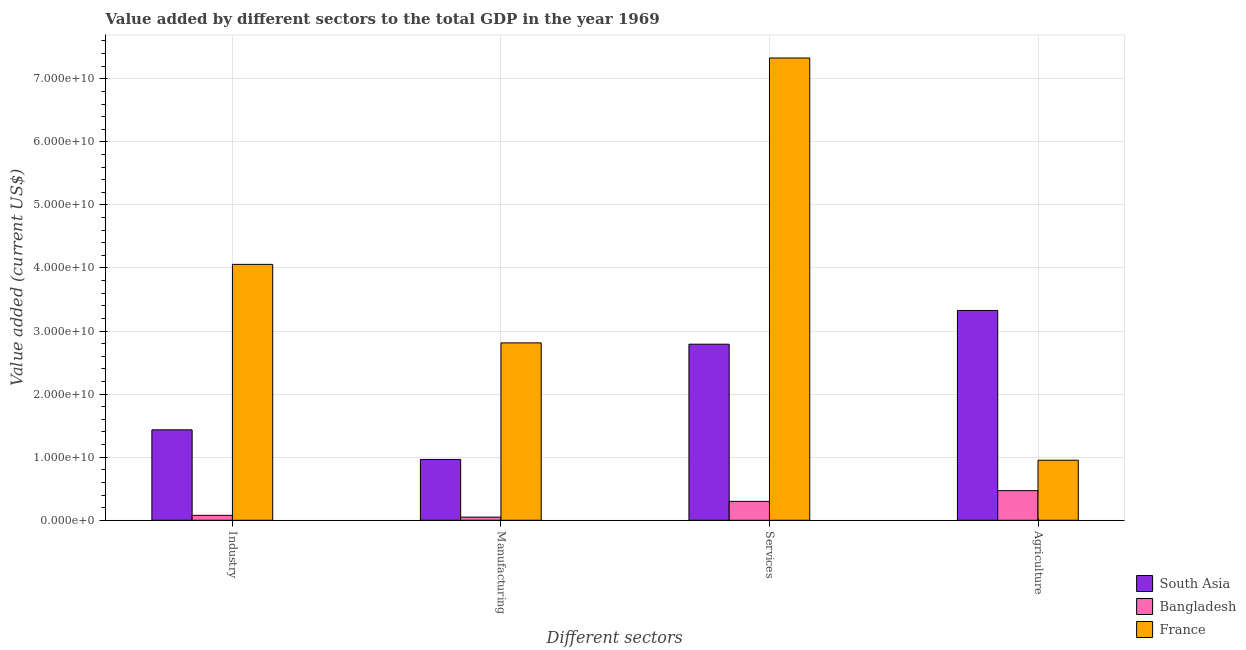How many different coloured bars are there?
Your response must be concise. 3. Are the number of bars per tick equal to the number of legend labels?
Offer a very short reply. Yes. Are the number of bars on each tick of the X-axis equal?
Keep it short and to the point. Yes. How many bars are there on the 1st tick from the left?
Your answer should be very brief. 3. How many bars are there on the 4th tick from the right?
Offer a terse response. 3. What is the label of the 2nd group of bars from the left?
Your answer should be very brief. Manufacturing. What is the value added by industrial sector in France?
Make the answer very short. 4.06e+1. Across all countries, what is the maximum value added by services sector?
Offer a very short reply. 7.33e+1. Across all countries, what is the minimum value added by services sector?
Provide a succinct answer. 3.00e+09. In which country was the value added by manufacturing sector maximum?
Keep it short and to the point. France. In which country was the value added by manufacturing sector minimum?
Your response must be concise. Bangladesh. What is the total value added by services sector in the graph?
Provide a short and direct response. 1.04e+11. What is the difference between the value added by agricultural sector in France and that in Bangladesh?
Give a very brief answer. 4.83e+09. What is the difference between the value added by services sector in South Asia and the value added by agricultural sector in Bangladesh?
Provide a short and direct response. 2.32e+1. What is the average value added by industrial sector per country?
Your answer should be compact. 1.86e+1. What is the difference between the value added by agricultural sector and value added by services sector in South Asia?
Provide a succinct answer. 5.35e+09. In how many countries, is the value added by services sector greater than 70000000000 US$?
Provide a succinct answer. 1. What is the ratio of the value added by industrial sector in France to that in Bangladesh?
Give a very brief answer. 52.14. Is the difference between the value added by services sector in Bangladesh and France greater than the difference between the value added by agricultural sector in Bangladesh and France?
Offer a terse response. No. What is the difference between the highest and the second highest value added by industrial sector?
Your answer should be compact. 2.62e+1. What is the difference between the highest and the lowest value added by manufacturing sector?
Provide a short and direct response. 2.76e+1. In how many countries, is the value added by manufacturing sector greater than the average value added by manufacturing sector taken over all countries?
Provide a short and direct response. 1. Are the values on the major ticks of Y-axis written in scientific E-notation?
Keep it short and to the point. Yes. How many legend labels are there?
Your response must be concise. 3. How are the legend labels stacked?
Offer a terse response. Vertical. What is the title of the graph?
Your answer should be very brief. Value added by different sectors to the total GDP in the year 1969. Does "Kenya" appear as one of the legend labels in the graph?
Your answer should be very brief. No. What is the label or title of the X-axis?
Make the answer very short. Different sectors. What is the label or title of the Y-axis?
Give a very brief answer. Value added (current US$). What is the Value added (current US$) in South Asia in Industry?
Give a very brief answer. 1.43e+1. What is the Value added (current US$) of Bangladesh in Industry?
Provide a succinct answer. 7.78e+08. What is the Value added (current US$) in France in Industry?
Offer a terse response. 4.06e+1. What is the Value added (current US$) in South Asia in Manufacturing?
Your answer should be compact. 9.64e+09. What is the Value added (current US$) of Bangladesh in Manufacturing?
Give a very brief answer. 4.96e+08. What is the Value added (current US$) of France in Manufacturing?
Offer a very short reply. 2.81e+1. What is the Value added (current US$) in South Asia in Services?
Offer a very short reply. 2.79e+1. What is the Value added (current US$) of Bangladesh in Services?
Offer a terse response. 3.00e+09. What is the Value added (current US$) of France in Services?
Your answer should be very brief. 7.33e+1. What is the Value added (current US$) of South Asia in Agriculture?
Your answer should be compact. 3.33e+1. What is the Value added (current US$) of Bangladesh in Agriculture?
Provide a succinct answer. 4.69e+09. What is the Value added (current US$) in France in Agriculture?
Offer a very short reply. 9.52e+09. Across all Different sectors, what is the maximum Value added (current US$) of South Asia?
Make the answer very short. 3.33e+1. Across all Different sectors, what is the maximum Value added (current US$) of Bangladesh?
Make the answer very short. 4.69e+09. Across all Different sectors, what is the maximum Value added (current US$) in France?
Your answer should be compact. 7.33e+1. Across all Different sectors, what is the minimum Value added (current US$) in South Asia?
Offer a very short reply. 9.64e+09. Across all Different sectors, what is the minimum Value added (current US$) of Bangladesh?
Offer a terse response. 4.96e+08. Across all Different sectors, what is the minimum Value added (current US$) in France?
Your response must be concise. 9.52e+09. What is the total Value added (current US$) in South Asia in the graph?
Your answer should be compact. 8.52e+1. What is the total Value added (current US$) in Bangladesh in the graph?
Provide a succinct answer. 8.97e+09. What is the total Value added (current US$) of France in the graph?
Offer a very short reply. 1.52e+11. What is the difference between the Value added (current US$) in South Asia in Industry and that in Manufacturing?
Provide a succinct answer. 4.69e+09. What is the difference between the Value added (current US$) of Bangladesh in Industry and that in Manufacturing?
Offer a terse response. 2.83e+08. What is the difference between the Value added (current US$) in France in Industry and that in Manufacturing?
Provide a succinct answer. 1.24e+1. What is the difference between the Value added (current US$) of South Asia in Industry and that in Services?
Give a very brief answer. -1.36e+1. What is the difference between the Value added (current US$) of Bangladesh in Industry and that in Services?
Your answer should be compact. -2.22e+09. What is the difference between the Value added (current US$) of France in Industry and that in Services?
Keep it short and to the point. -3.27e+1. What is the difference between the Value added (current US$) in South Asia in Industry and that in Agriculture?
Offer a terse response. -1.89e+1. What is the difference between the Value added (current US$) of Bangladesh in Industry and that in Agriculture?
Keep it short and to the point. -3.92e+09. What is the difference between the Value added (current US$) of France in Industry and that in Agriculture?
Provide a succinct answer. 3.11e+1. What is the difference between the Value added (current US$) of South Asia in Manufacturing and that in Services?
Give a very brief answer. -1.83e+1. What is the difference between the Value added (current US$) in Bangladesh in Manufacturing and that in Services?
Provide a short and direct response. -2.50e+09. What is the difference between the Value added (current US$) in France in Manufacturing and that in Services?
Provide a succinct answer. -4.52e+1. What is the difference between the Value added (current US$) in South Asia in Manufacturing and that in Agriculture?
Your answer should be very brief. -2.36e+1. What is the difference between the Value added (current US$) of Bangladesh in Manufacturing and that in Agriculture?
Provide a short and direct response. -4.20e+09. What is the difference between the Value added (current US$) in France in Manufacturing and that in Agriculture?
Make the answer very short. 1.86e+1. What is the difference between the Value added (current US$) of South Asia in Services and that in Agriculture?
Provide a succinct answer. -5.35e+09. What is the difference between the Value added (current US$) of Bangladesh in Services and that in Agriculture?
Your answer should be compact. -1.70e+09. What is the difference between the Value added (current US$) of France in Services and that in Agriculture?
Keep it short and to the point. 6.38e+1. What is the difference between the Value added (current US$) in South Asia in Industry and the Value added (current US$) in Bangladesh in Manufacturing?
Provide a short and direct response. 1.38e+1. What is the difference between the Value added (current US$) of South Asia in Industry and the Value added (current US$) of France in Manufacturing?
Your answer should be very brief. -1.38e+1. What is the difference between the Value added (current US$) in Bangladesh in Industry and the Value added (current US$) in France in Manufacturing?
Ensure brevity in your answer.  -2.73e+1. What is the difference between the Value added (current US$) of South Asia in Industry and the Value added (current US$) of Bangladesh in Services?
Your response must be concise. 1.13e+1. What is the difference between the Value added (current US$) in South Asia in Industry and the Value added (current US$) in France in Services?
Offer a terse response. -5.90e+1. What is the difference between the Value added (current US$) in Bangladesh in Industry and the Value added (current US$) in France in Services?
Your answer should be very brief. -7.25e+1. What is the difference between the Value added (current US$) in South Asia in Industry and the Value added (current US$) in Bangladesh in Agriculture?
Provide a succinct answer. 9.64e+09. What is the difference between the Value added (current US$) in South Asia in Industry and the Value added (current US$) in France in Agriculture?
Your answer should be very brief. 4.81e+09. What is the difference between the Value added (current US$) in Bangladesh in Industry and the Value added (current US$) in France in Agriculture?
Provide a succinct answer. -8.75e+09. What is the difference between the Value added (current US$) in South Asia in Manufacturing and the Value added (current US$) in Bangladesh in Services?
Keep it short and to the point. 6.64e+09. What is the difference between the Value added (current US$) in South Asia in Manufacturing and the Value added (current US$) in France in Services?
Provide a short and direct response. -6.37e+1. What is the difference between the Value added (current US$) of Bangladesh in Manufacturing and the Value added (current US$) of France in Services?
Provide a succinct answer. -7.28e+1. What is the difference between the Value added (current US$) in South Asia in Manufacturing and the Value added (current US$) in Bangladesh in Agriculture?
Your answer should be very brief. 4.95e+09. What is the difference between the Value added (current US$) in South Asia in Manufacturing and the Value added (current US$) in France in Agriculture?
Make the answer very short. 1.19e+08. What is the difference between the Value added (current US$) of Bangladesh in Manufacturing and the Value added (current US$) of France in Agriculture?
Offer a very short reply. -9.03e+09. What is the difference between the Value added (current US$) of South Asia in Services and the Value added (current US$) of Bangladesh in Agriculture?
Your answer should be very brief. 2.32e+1. What is the difference between the Value added (current US$) of South Asia in Services and the Value added (current US$) of France in Agriculture?
Your answer should be very brief. 1.84e+1. What is the difference between the Value added (current US$) in Bangladesh in Services and the Value added (current US$) in France in Agriculture?
Provide a short and direct response. -6.52e+09. What is the average Value added (current US$) of South Asia per Different sectors?
Offer a terse response. 2.13e+1. What is the average Value added (current US$) of Bangladesh per Different sectors?
Provide a short and direct response. 2.24e+09. What is the average Value added (current US$) of France per Different sectors?
Give a very brief answer. 3.79e+1. What is the difference between the Value added (current US$) in South Asia and Value added (current US$) in Bangladesh in Industry?
Provide a short and direct response. 1.36e+1. What is the difference between the Value added (current US$) of South Asia and Value added (current US$) of France in Industry?
Keep it short and to the point. -2.62e+1. What is the difference between the Value added (current US$) in Bangladesh and Value added (current US$) in France in Industry?
Keep it short and to the point. -3.98e+1. What is the difference between the Value added (current US$) in South Asia and Value added (current US$) in Bangladesh in Manufacturing?
Offer a terse response. 9.15e+09. What is the difference between the Value added (current US$) of South Asia and Value added (current US$) of France in Manufacturing?
Your answer should be very brief. -1.85e+1. What is the difference between the Value added (current US$) of Bangladesh and Value added (current US$) of France in Manufacturing?
Your response must be concise. -2.76e+1. What is the difference between the Value added (current US$) of South Asia and Value added (current US$) of Bangladesh in Services?
Ensure brevity in your answer.  2.49e+1. What is the difference between the Value added (current US$) of South Asia and Value added (current US$) of France in Services?
Your response must be concise. -4.54e+1. What is the difference between the Value added (current US$) in Bangladesh and Value added (current US$) in France in Services?
Make the answer very short. -7.03e+1. What is the difference between the Value added (current US$) of South Asia and Value added (current US$) of Bangladesh in Agriculture?
Offer a terse response. 2.86e+1. What is the difference between the Value added (current US$) of South Asia and Value added (current US$) of France in Agriculture?
Provide a short and direct response. 2.37e+1. What is the difference between the Value added (current US$) in Bangladesh and Value added (current US$) in France in Agriculture?
Give a very brief answer. -4.83e+09. What is the ratio of the Value added (current US$) of South Asia in Industry to that in Manufacturing?
Ensure brevity in your answer.  1.49. What is the ratio of the Value added (current US$) of Bangladesh in Industry to that in Manufacturing?
Offer a terse response. 1.57. What is the ratio of the Value added (current US$) in France in Industry to that in Manufacturing?
Ensure brevity in your answer.  1.44. What is the ratio of the Value added (current US$) of South Asia in Industry to that in Services?
Keep it short and to the point. 0.51. What is the ratio of the Value added (current US$) in Bangladesh in Industry to that in Services?
Provide a succinct answer. 0.26. What is the ratio of the Value added (current US$) in France in Industry to that in Services?
Your answer should be very brief. 0.55. What is the ratio of the Value added (current US$) in South Asia in Industry to that in Agriculture?
Give a very brief answer. 0.43. What is the ratio of the Value added (current US$) in Bangladesh in Industry to that in Agriculture?
Your answer should be very brief. 0.17. What is the ratio of the Value added (current US$) in France in Industry to that in Agriculture?
Ensure brevity in your answer.  4.26. What is the ratio of the Value added (current US$) of South Asia in Manufacturing to that in Services?
Make the answer very short. 0.35. What is the ratio of the Value added (current US$) of Bangladesh in Manufacturing to that in Services?
Make the answer very short. 0.17. What is the ratio of the Value added (current US$) in France in Manufacturing to that in Services?
Provide a short and direct response. 0.38. What is the ratio of the Value added (current US$) in South Asia in Manufacturing to that in Agriculture?
Give a very brief answer. 0.29. What is the ratio of the Value added (current US$) in Bangladesh in Manufacturing to that in Agriculture?
Provide a short and direct response. 0.11. What is the ratio of the Value added (current US$) of France in Manufacturing to that in Agriculture?
Your response must be concise. 2.95. What is the ratio of the Value added (current US$) of South Asia in Services to that in Agriculture?
Provide a short and direct response. 0.84. What is the ratio of the Value added (current US$) of Bangladesh in Services to that in Agriculture?
Your response must be concise. 0.64. What is the ratio of the Value added (current US$) in France in Services to that in Agriculture?
Give a very brief answer. 7.7. What is the difference between the highest and the second highest Value added (current US$) in South Asia?
Ensure brevity in your answer.  5.35e+09. What is the difference between the highest and the second highest Value added (current US$) of Bangladesh?
Offer a terse response. 1.70e+09. What is the difference between the highest and the second highest Value added (current US$) of France?
Give a very brief answer. 3.27e+1. What is the difference between the highest and the lowest Value added (current US$) of South Asia?
Offer a very short reply. 2.36e+1. What is the difference between the highest and the lowest Value added (current US$) of Bangladesh?
Offer a very short reply. 4.20e+09. What is the difference between the highest and the lowest Value added (current US$) in France?
Offer a terse response. 6.38e+1. 